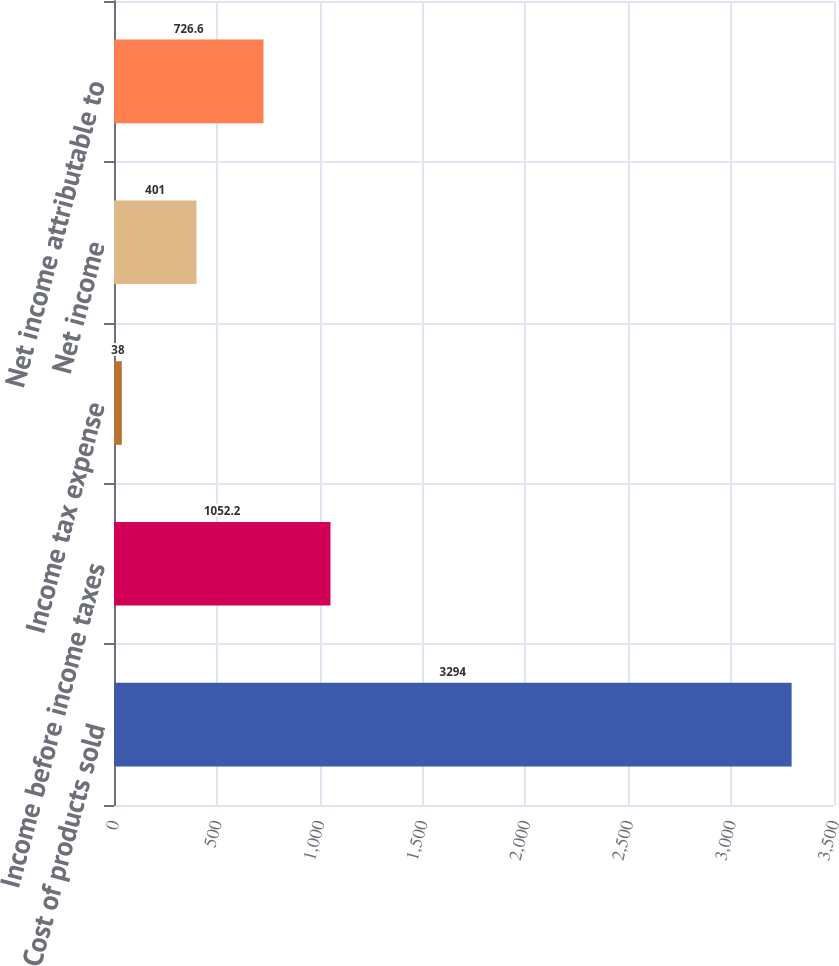Convert chart. <chart><loc_0><loc_0><loc_500><loc_500><bar_chart><fcel>Cost of products sold<fcel>Income before income taxes<fcel>Income tax expense<fcel>Net income<fcel>Net income attributable to<nl><fcel>3294<fcel>1052.2<fcel>38<fcel>401<fcel>726.6<nl></chart> 